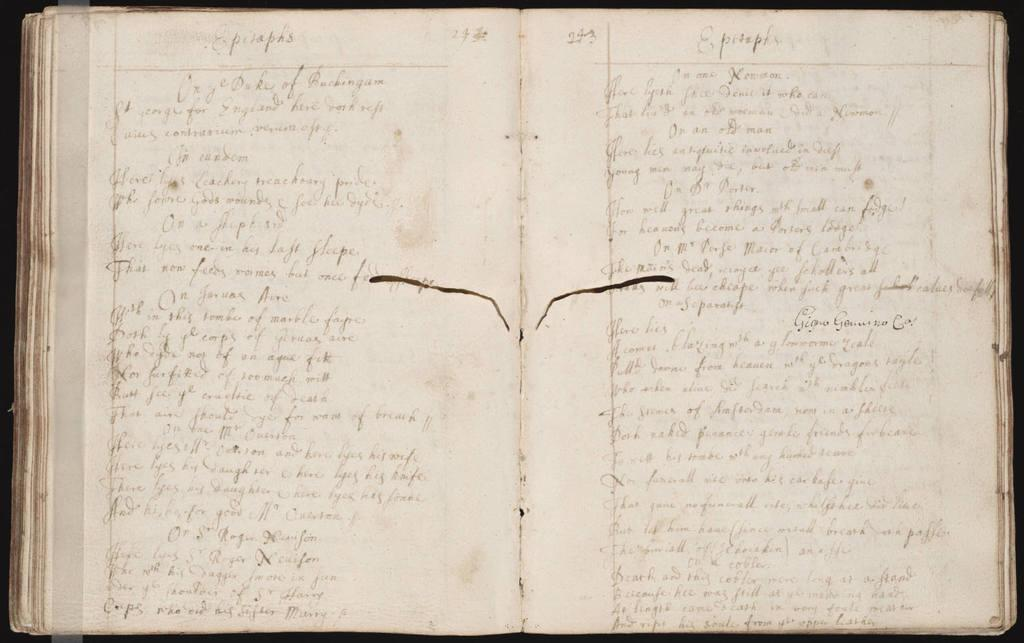<image>
Write a terse but informative summary of the picture. Open book showing the word EPITAPHS on the top. 